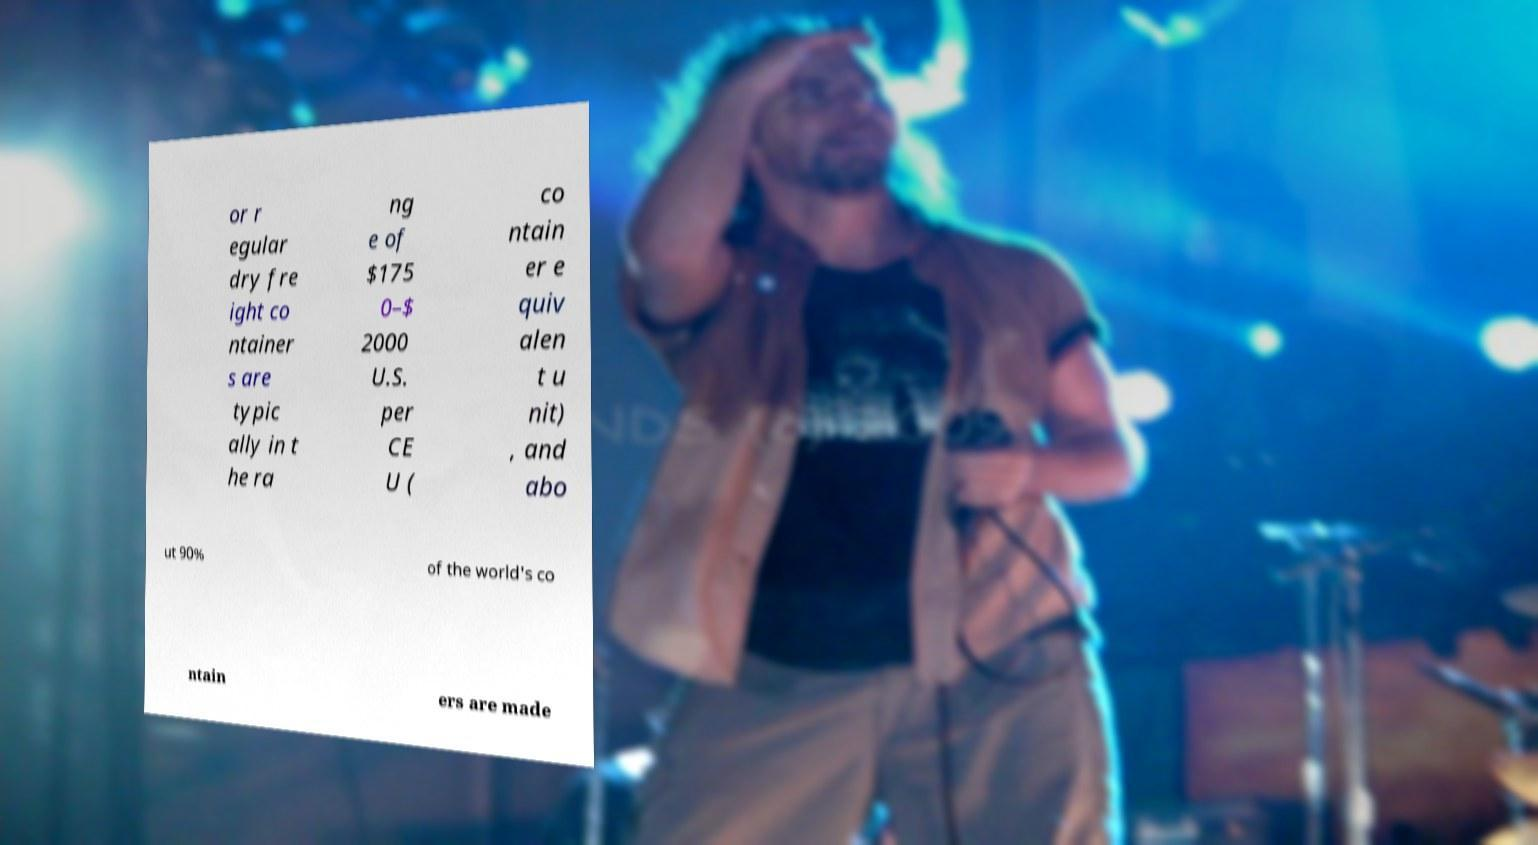Could you assist in decoding the text presented in this image and type it out clearly? or r egular dry fre ight co ntainer s are typic ally in t he ra ng e of $175 0–$ 2000 U.S. per CE U ( co ntain er e quiv alen t u nit) , and abo ut 90% of the world's co ntain ers are made 